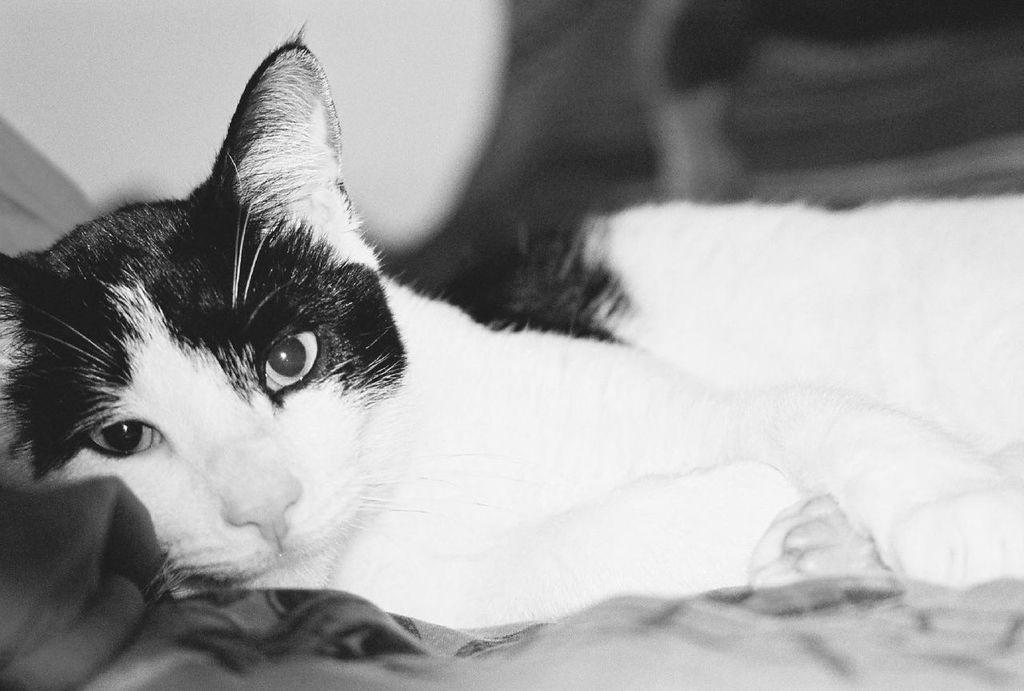What type of animal is present in the image? There is a cat in the image. What is the cat doing in the image? The cat is sleeping. What color scheme is used in the image? The image is in black and white. What type of office equipment can be seen in the image? There is no office equipment present in the image; it features a sleeping cat in black and white. What type of ink is used to create the image? The image is in black and white, so there is no ink used to create the image. 